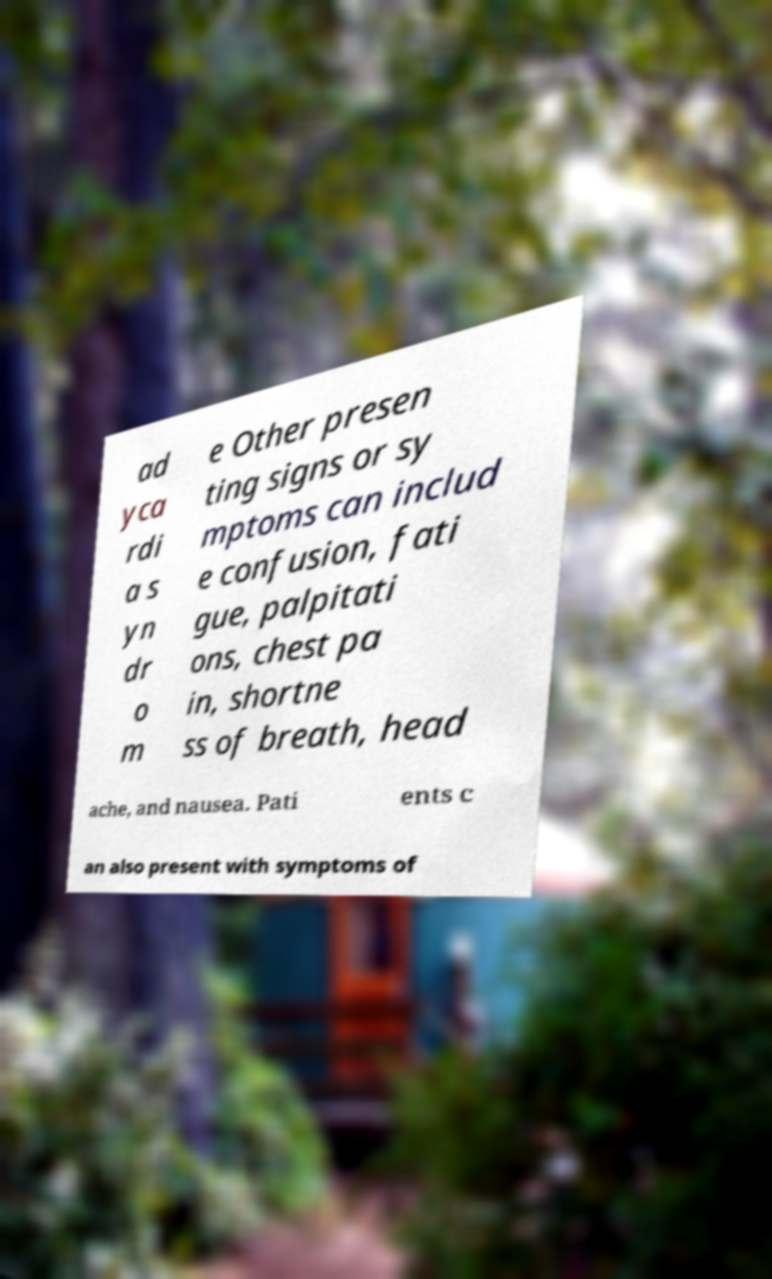Can you read and provide the text displayed in the image?This photo seems to have some interesting text. Can you extract and type it out for me? ad yca rdi a s yn dr o m e Other presen ting signs or sy mptoms can includ e confusion, fati gue, palpitati ons, chest pa in, shortne ss of breath, head ache, and nausea. Pati ents c an also present with symptoms of 